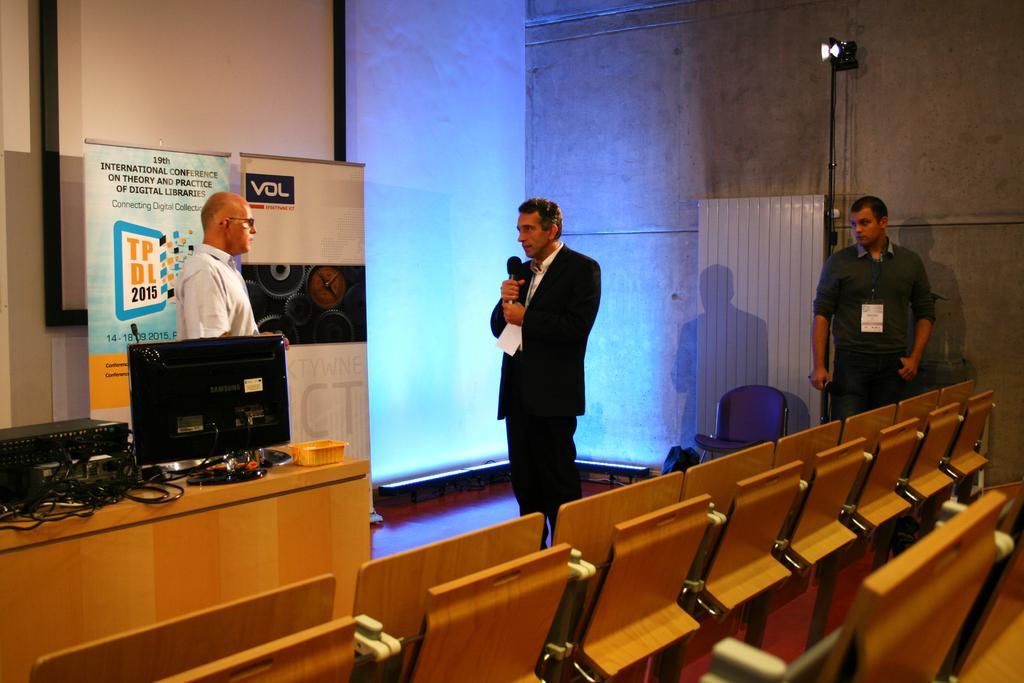Please provide a concise description of this image. In a hall,there are total three people standing there are brown color chairs in front of that there is a table, on the table there is a monitor to the left side there is a music system, in front of that a man wearing white color shirt is standing beside him another person is speaking, in the background there are two banners behind them there is a presentation screen, to the right side there is a wall. 